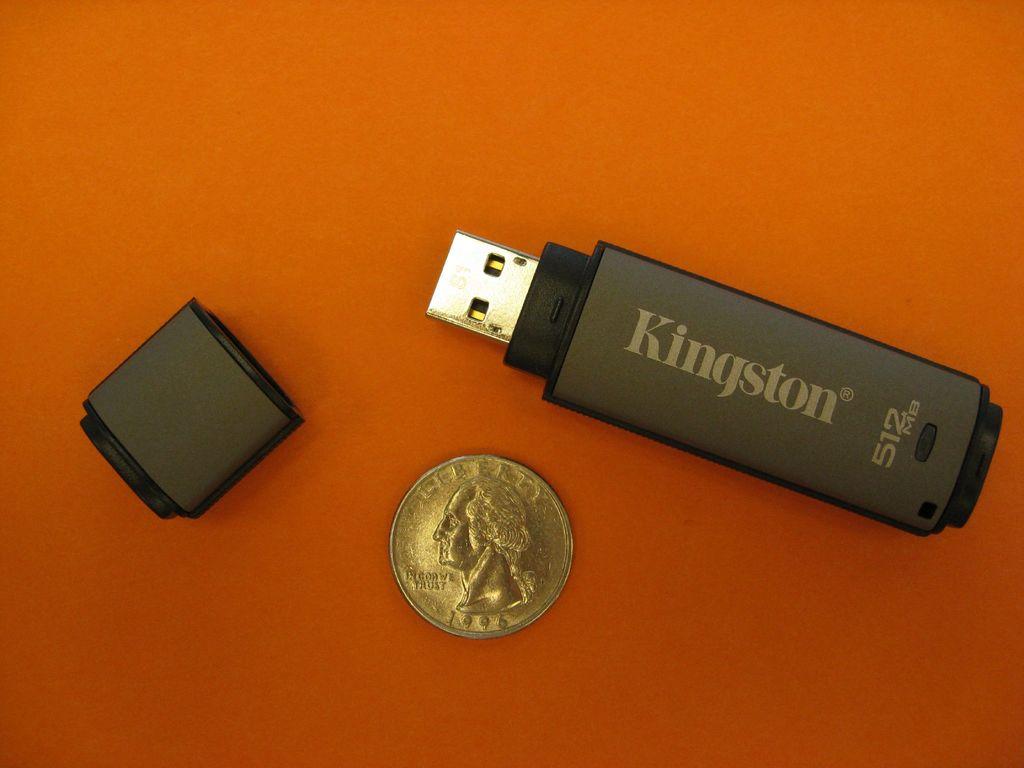How much space will the thumb drive hold?
Provide a succinct answer. 512mb. What is the brand of the thumb drive?
Offer a very short reply. Kingston. 